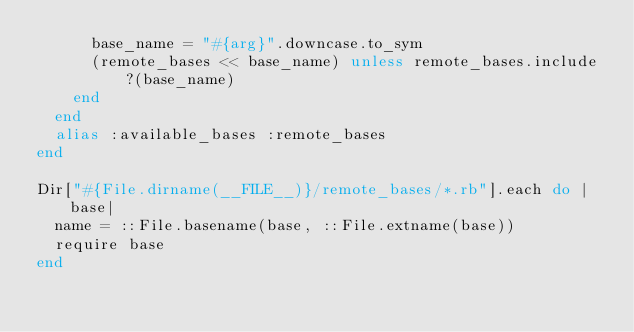Convert code to text. <code><loc_0><loc_0><loc_500><loc_500><_Ruby_>      base_name = "#{arg}".downcase.to_sym
      (remote_bases << base_name) unless remote_bases.include?(base_name)
    end
  end
  alias :available_bases :remote_bases
end

Dir["#{File.dirname(__FILE__)}/remote_bases/*.rb"].each do |base| 
  name = ::File.basename(base, ::File.extname(base))
  require base
end
</code> 